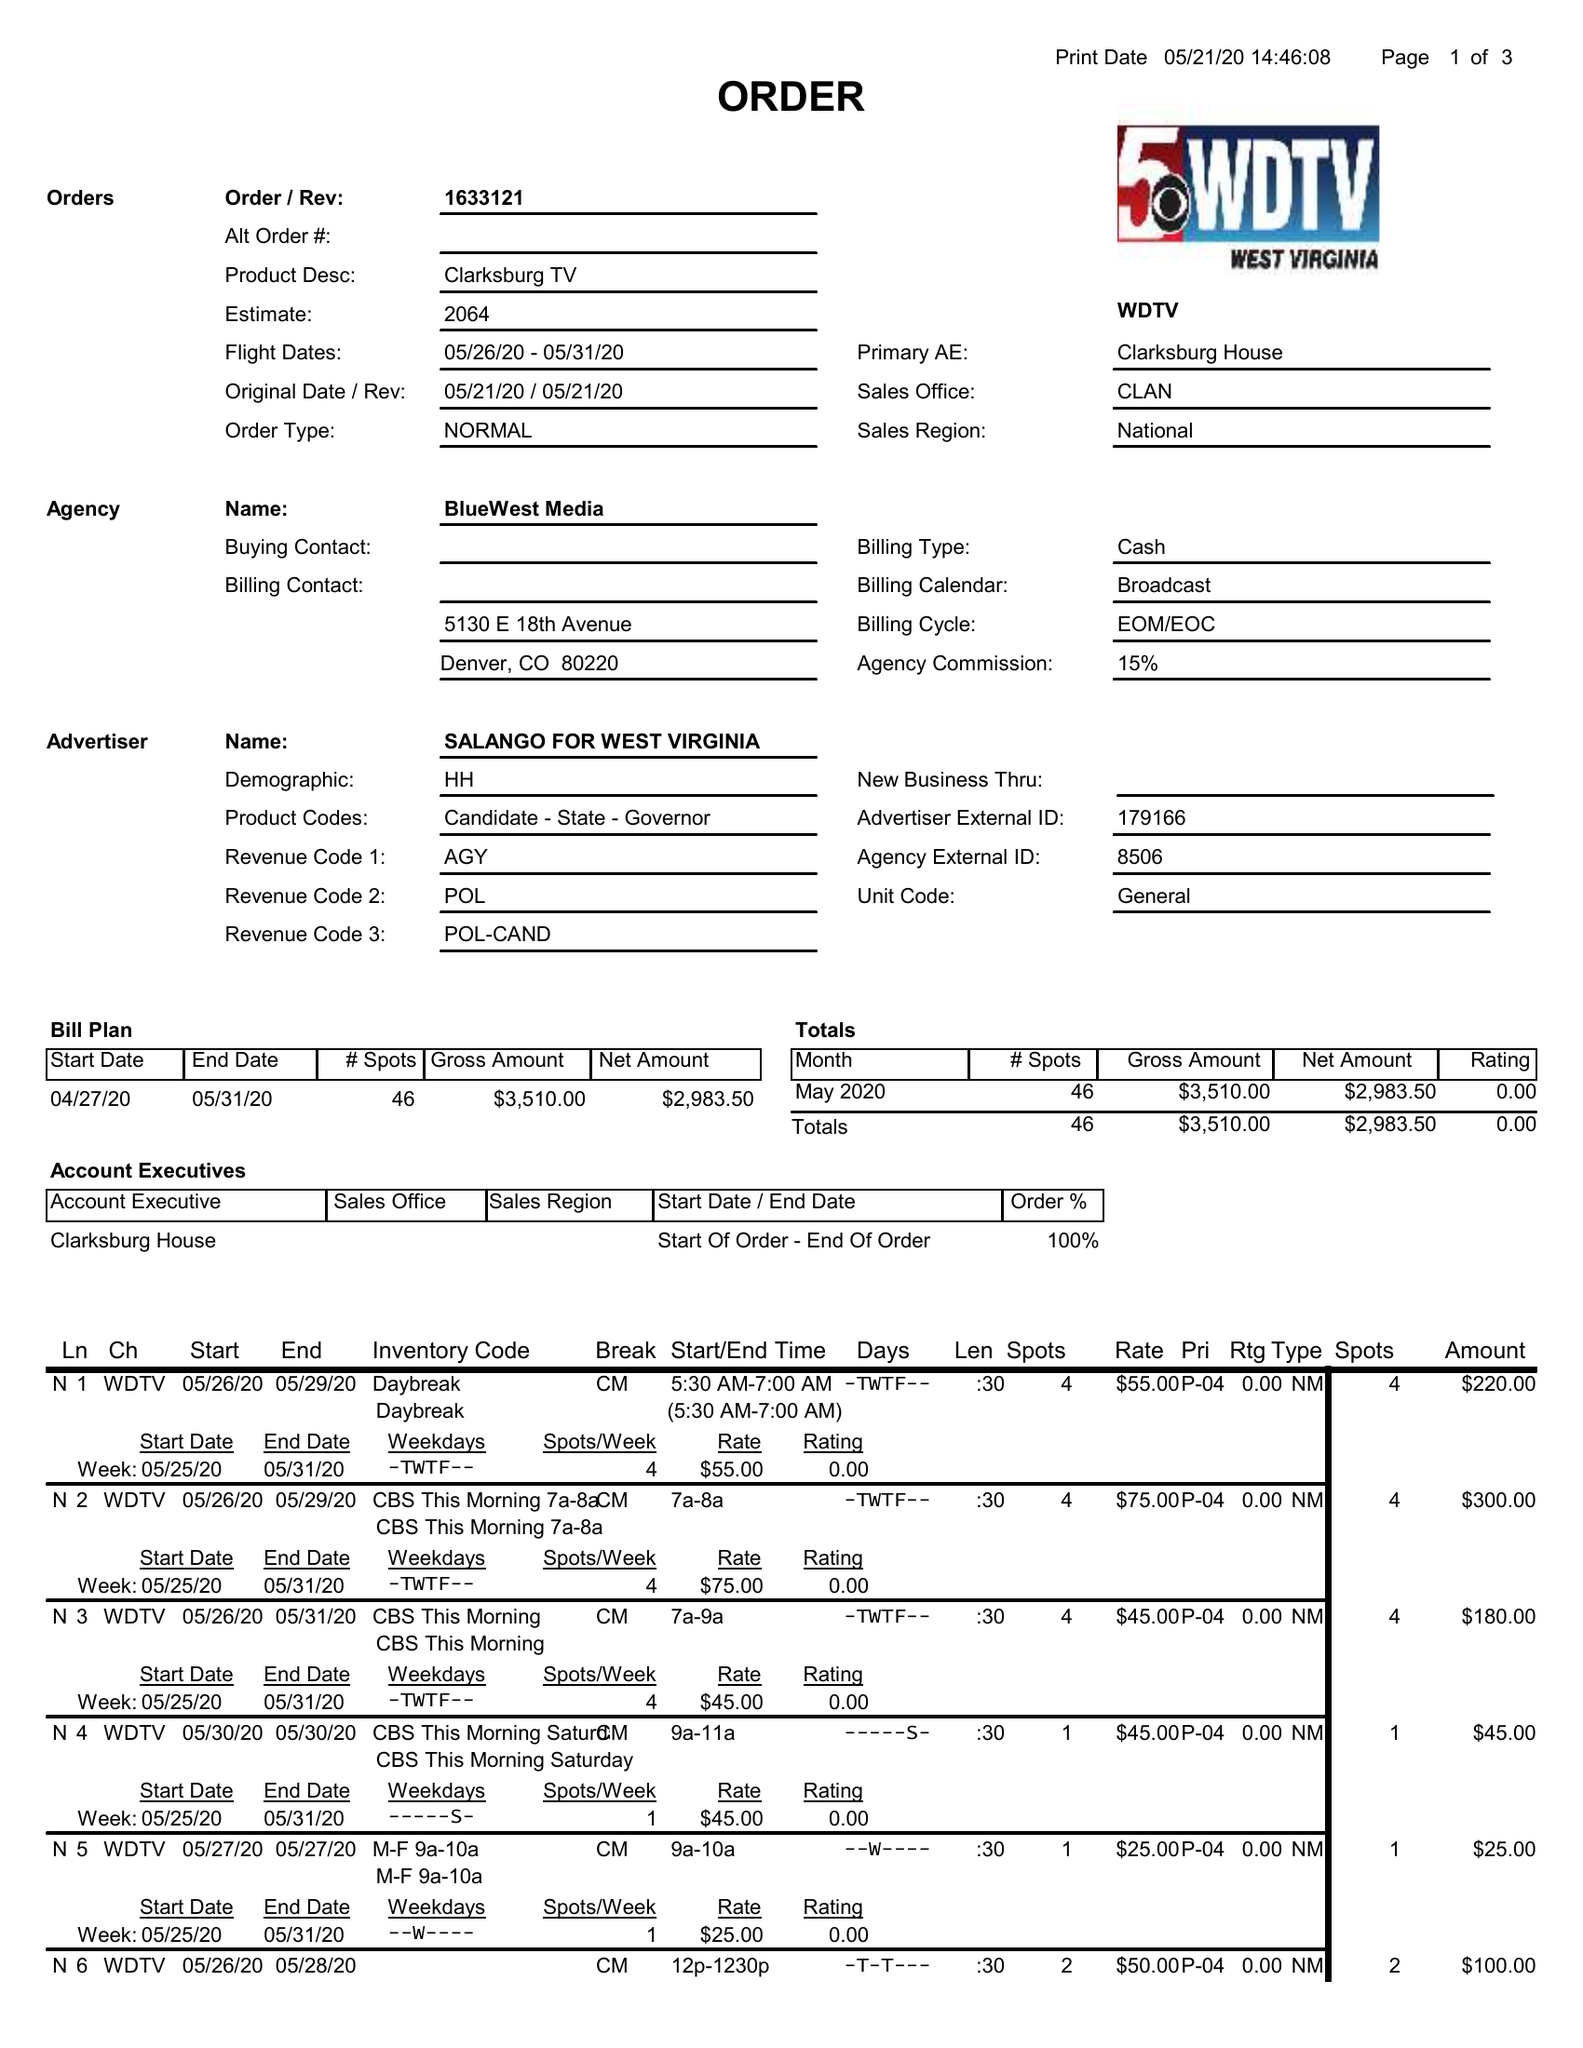What is the value for the gross_amount?
Answer the question using a single word or phrase. 3510.00 